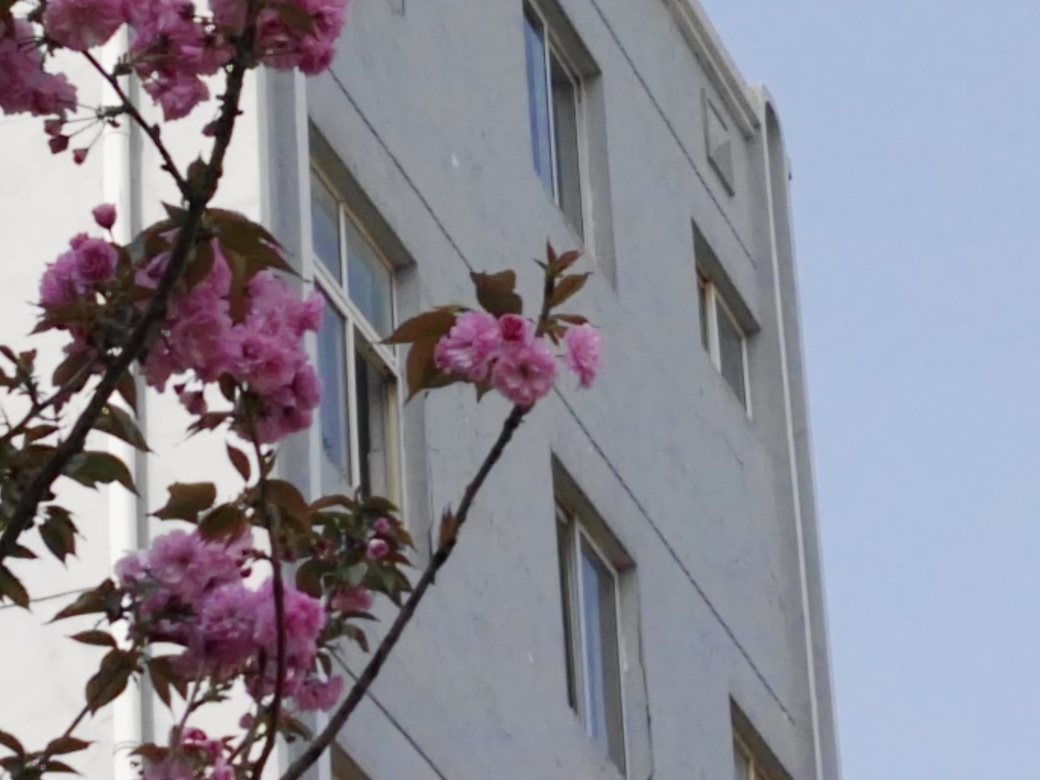Can you tell me more about the flora in the image? The image features a branch of pink blooms, likely cherry blossoms or a similar variety, characterized by their vibrant color and the dense clustering of flowers. They provide a striking visual contrast to the urban backdrop and are often associated with the spring season and themes of renewal and beauty. 